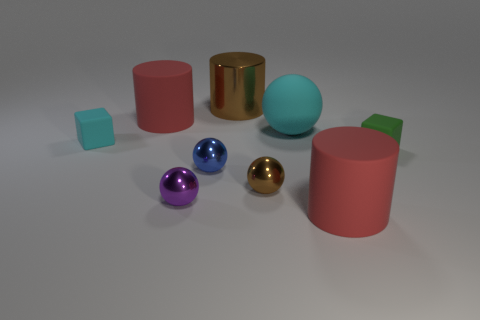How big is the red matte cylinder right of the metal cylinder that is behind the small green object?
Ensure brevity in your answer.  Large. There is another object that is the same shape as the small cyan thing; what color is it?
Make the answer very short. Green. There is a green rubber object that is the same shape as the tiny cyan rubber thing; what is its size?
Give a very brief answer. Small. There is a tiny green thing that is behind the small blue shiny object; is it the same shape as the small cyan object?
Provide a short and direct response. Yes. What size is the thing that is the same color as the rubber ball?
Offer a very short reply. Small. There is a purple sphere that is in front of the large cyan matte object in front of the brown metallic thing that is behind the blue shiny thing; what is its material?
Your response must be concise. Metal. There is a red matte thing that is in front of the cyan sphere; what shape is it?
Give a very brief answer. Cylinder. There is a green block that is made of the same material as the cyan cube; what is its size?
Give a very brief answer. Small. What number of cyan rubber things have the same shape as the large shiny thing?
Provide a short and direct response. 0. Do the small rubber block on the left side of the small brown shiny ball and the large ball have the same color?
Provide a short and direct response. Yes. 